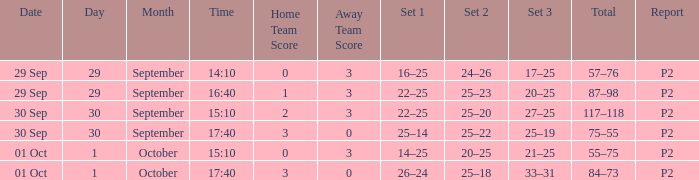On september 29 at 16:40, what would be the appropriate set 3? 20–25. 